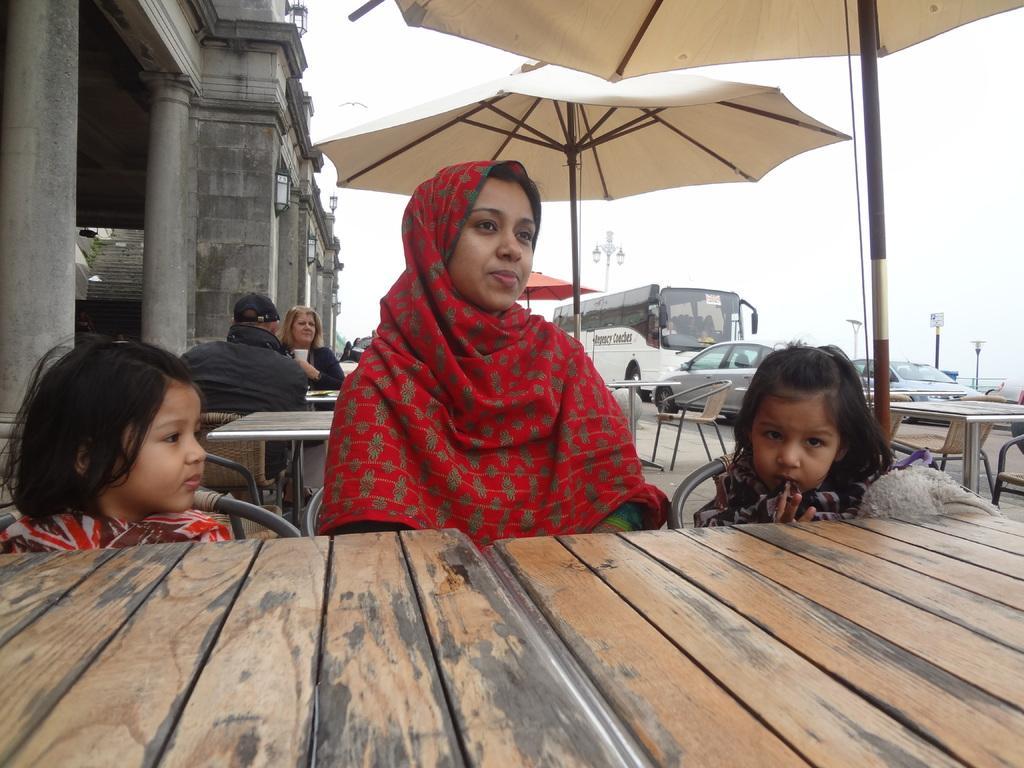What are the people in the image doing? The people in the image are sitting around tables. What objects are providing shade in the image? Umbrellas are present in the image to provide shade. What type of structure can be seen in the image? There is a building in the image. What can be seen moving on the road in the image? Vehicles are visible on the road in the image. Where are the lights located in the image? The lights are on a pole in the image. What type of cheese is being served on the map in the image? There is no cheese or map present in the image. 